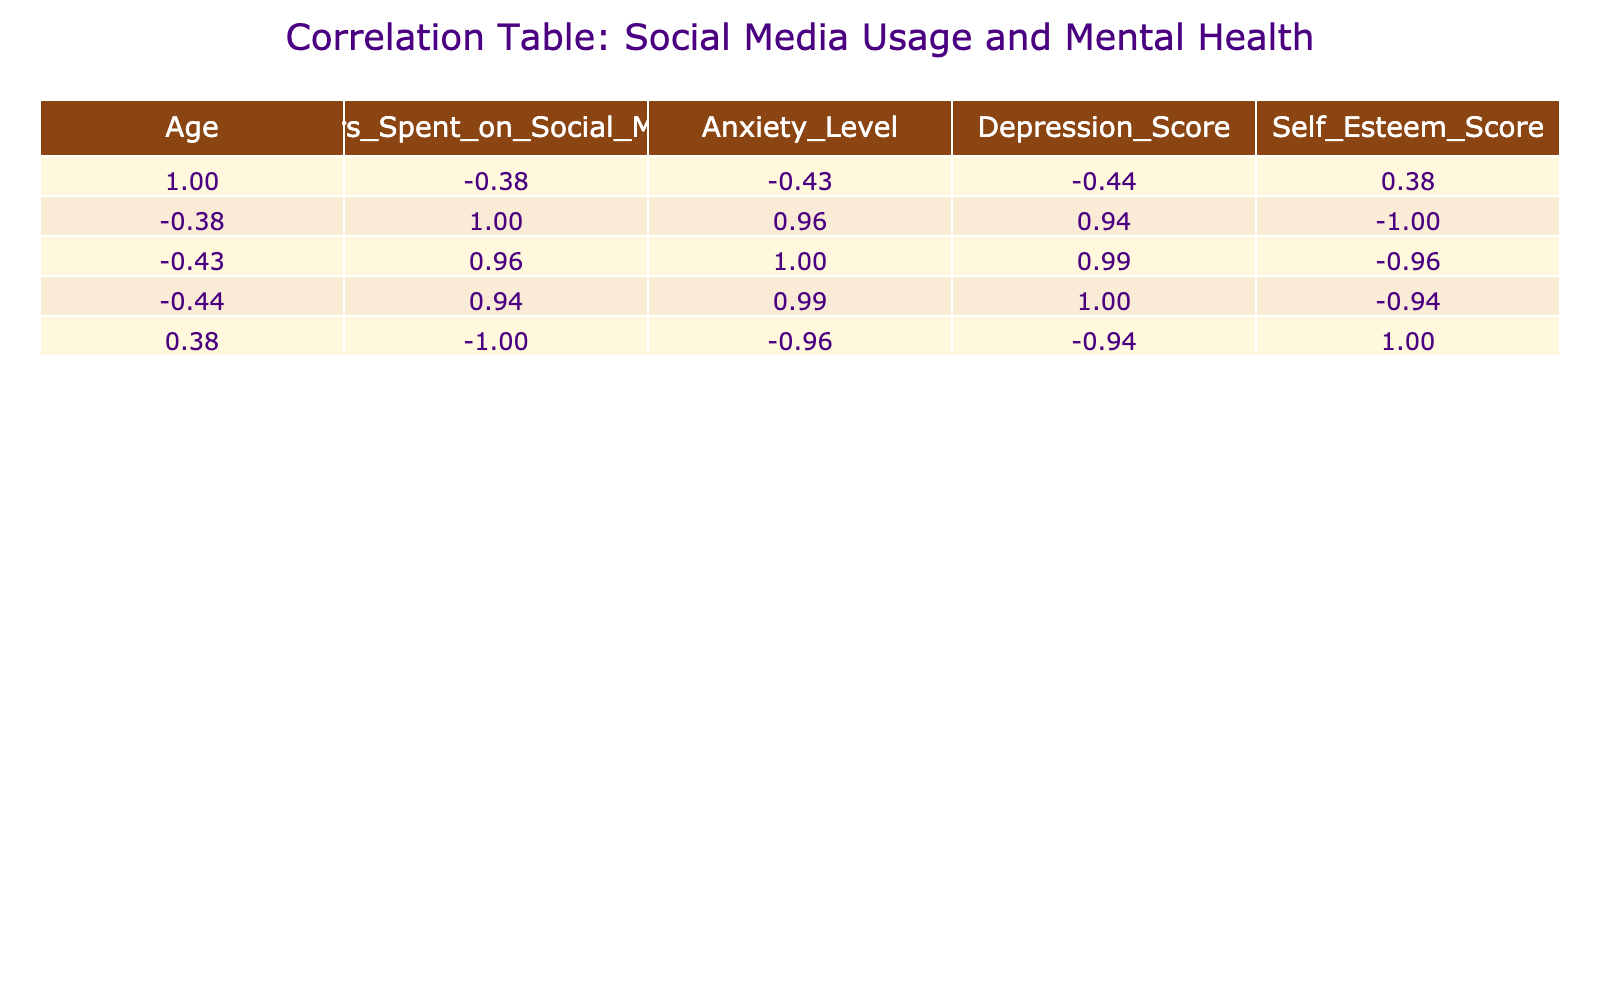What is the correlation between hours spent on social media and anxiety level? By examining the correlation table, we look at the "Hours_Spent_on_Social_Media" and "Anxiety_Level" columns. The value in the intersection of these two variables indicates a positive correlation, indicating that as the hours spent on social media increases, anxiety levels tend to increase as well.
Answer: Positive correlation Is there a negative correlation between age and self-esteem score? Check the correlation coefficient between "Age" and "Self_Esteem_Score". A negative value in this intersection indicates that as age increases, self-esteem tends to decrease.
Answer: Yes What are the anxiety level scores for the youngest and oldest teenagers in the data? The youngest teenager (age 14) has an anxiety level score of 7, and the oldest teenager (age 17) has an anxiety level score of 3.
Answer: 7 and 3 What is the average depression score for teenagers who spend more than 4 hours on social media? We identify teenagers from the dataset who spend more than 4 hours on social media: those ages 14 (depression score 10), 16 (depression score 9), and 15 (depression score 10). We sum these scores (10 + 9 + 10 = 29) and divide by 3 to find the average, which is 29/3 = 9.67.
Answer: 9.67 Is the correlation between social media usage and depression score stronger than that with anxiety level? We compare the correlation coefficients between "Hours_Spent_on_Social_Media" with "Depression_Score" and "Anxiety_Level". If the correlation value for depression is greater (in absolute terms) than that for anxiety, then it implies a stronger correlation. From the table, if the values confirm this, then the statement holds true.
Answer: Yes 